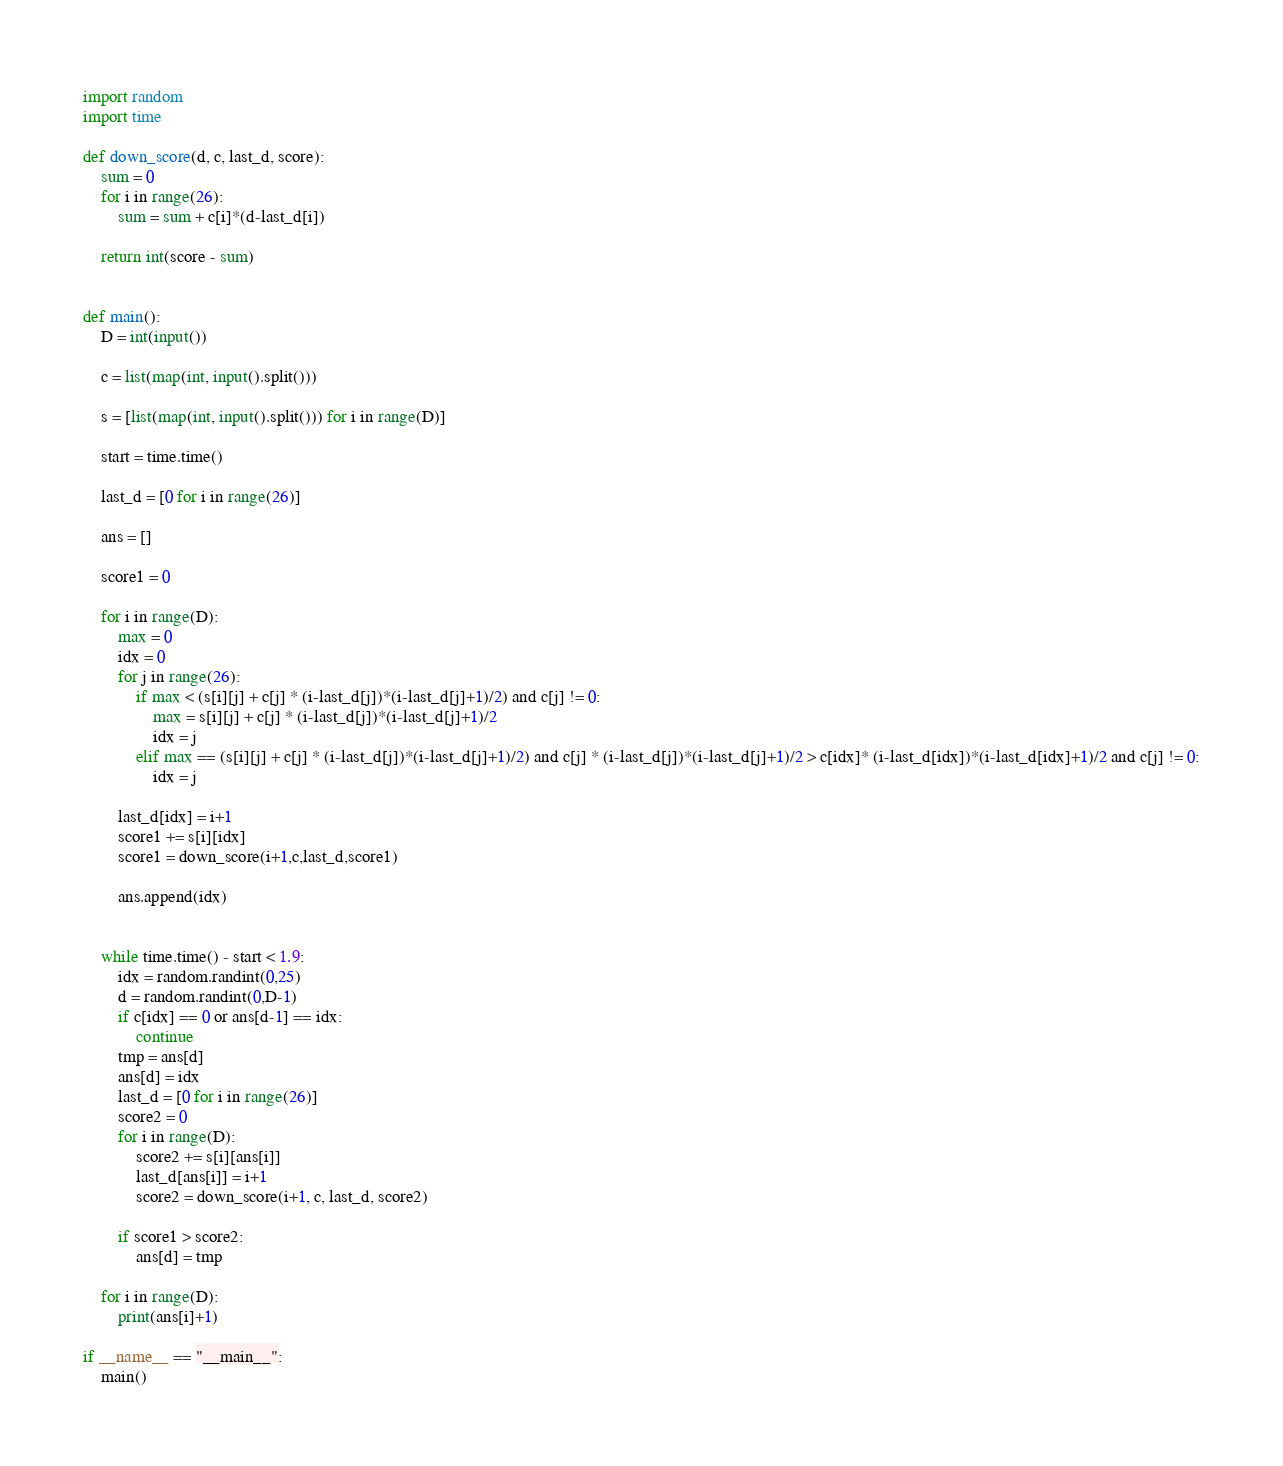<code> <loc_0><loc_0><loc_500><loc_500><_Python_>import random
import time

def down_score(d, c, last_d, score):
    sum = 0
    for i in range(26):
        sum = sum + c[i]*(d-last_d[i])
        
    return int(score - sum)


def main():
    D = int(input())

    c = list(map(int, input().split()))

    s = [list(map(int, input().split())) for i in range(D)]

    start = time.time()
    
    last_d = [0 for i in range(26)]
    
    ans = []
    
    score1 = 0
    
    for i in range(D):
        max = 0
        idx = 0
        for j in range(26):
            if max < (s[i][j] + c[j] * (i-last_d[j])*(i-last_d[j]+1)/2) and c[j] != 0:
                max = s[i][j] + c[j] * (i-last_d[j])*(i-last_d[j]+1)/2
                idx = j
            elif max == (s[i][j] + c[j] * (i-last_d[j])*(i-last_d[j]+1)/2) and c[j] * (i-last_d[j])*(i-last_d[j]+1)/2 > c[idx]* (i-last_d[idx])*(i-last_d[idx]+1)/2 and c[j] != 0:
                idx = j
            
        last_d[idx] = i+1
        score1 += s[i][idx]
        score1 = down_score(i+1,c,last_d,score1)
        
        ans.append(idx)


    while time.time() - start < 1.9:
        idx = random.randint(0,25)
        d = random.randint(0,D-1)
        if c[idx] == 0 or ans[d-1] == idx:
            continue
        tmp = ans[d]
        ans[d] = idx
        last_d = [0 for i in range(26)]
        score2 = 0    
        for i in range(D):
            score2 += s[i][ans[i]]
            last_d[ans[i]] = i+1
            score2 = down_score(i+1, c, last_d, score2)
        
        if score1 > score2:
            ans[d] = tmp
    
    for i in range(D):
        print(ans[i]+1)  

if __name__ == "__main__":
    main()
</code> 